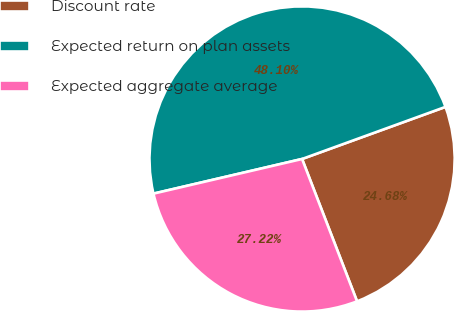Convert chart to OTSL. <chart><loc_0><loc_0><loc_500><loc_500><pie_chart><fcel>Discount rate<fcel>Expected return on plan assets<fcel>Expected aggregate average<nl><fcel>24.68%<fcel>48.1%<fcel>27.22%<nl></chart> 